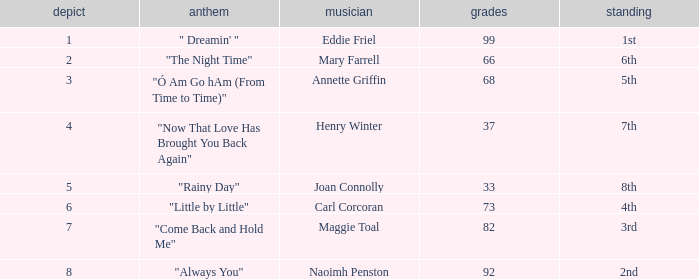When ranked 1st, what is the lowest possible points? 99.0. 